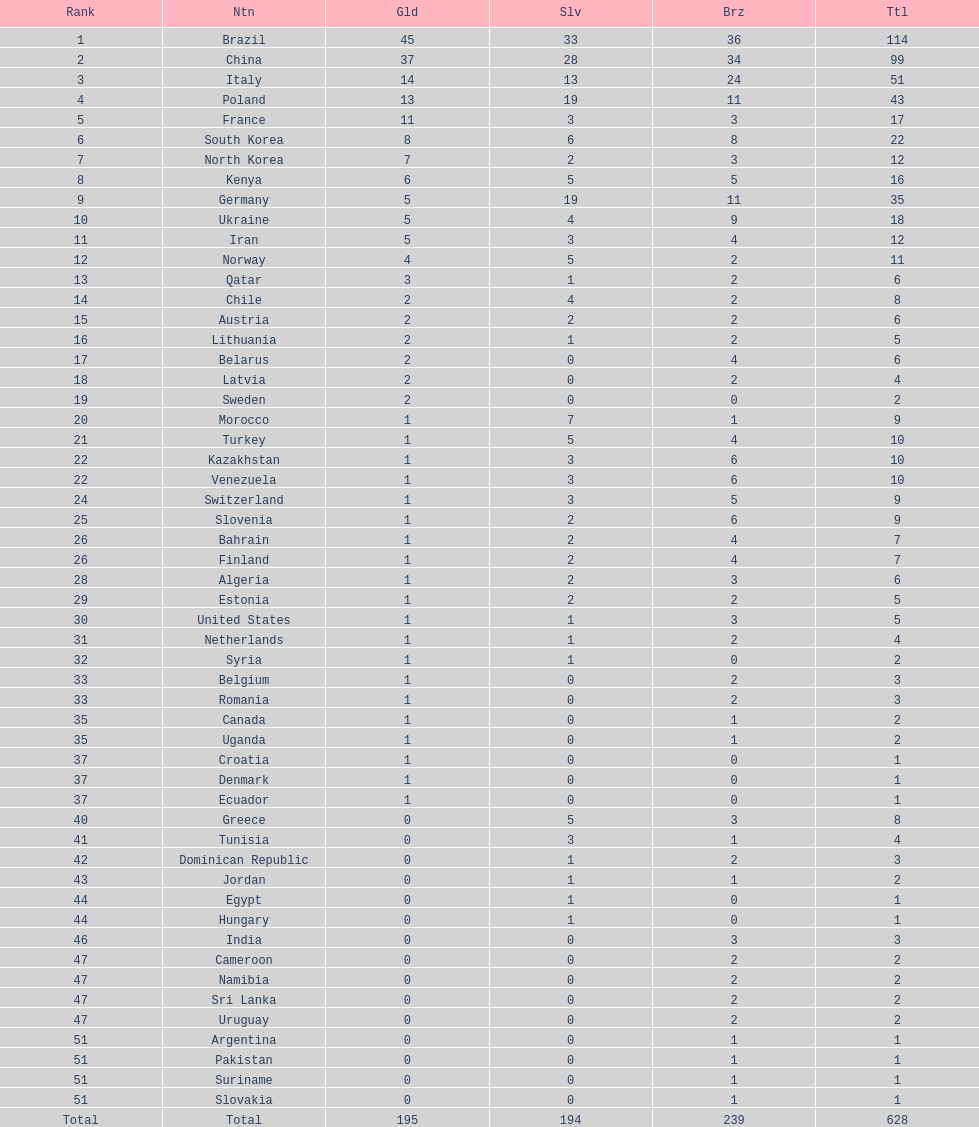Which type of medal does belarus not have? Silver. 